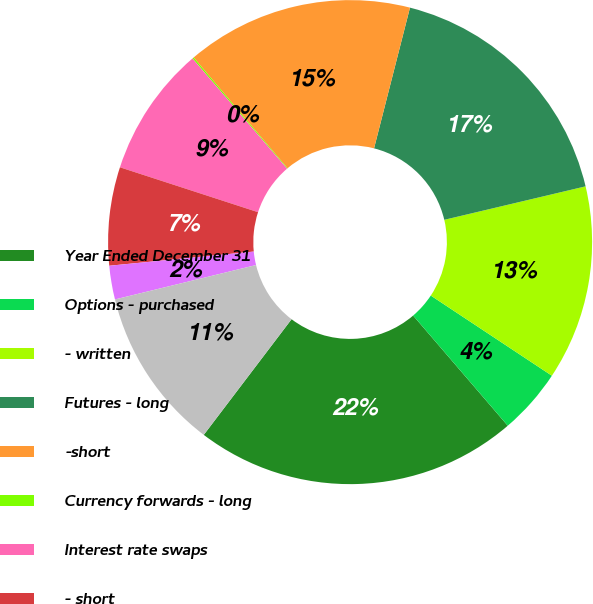Convert chart to OTSL. <chart><loc_0><loc_0><loc_500><loc_500><pie_chart><fcel>Year Ended December 31<fcel>Options - purchased<fcel>- written<fcel>Futures - long<fcel>-short<fcel>Currency forwards - long<fcel>Interest rate swaps<fcel>- short<fcel>Other<fcel>Total<nl><fcel>21.63%<fcel>4.4%<fcel>13.01%<fcel>17.32%<fcel>15.17%<fcel>0.1%<fcel>8.71%<fcel>6.56%<fcel>2.25%<fcel>10.86%<nl></chart> 